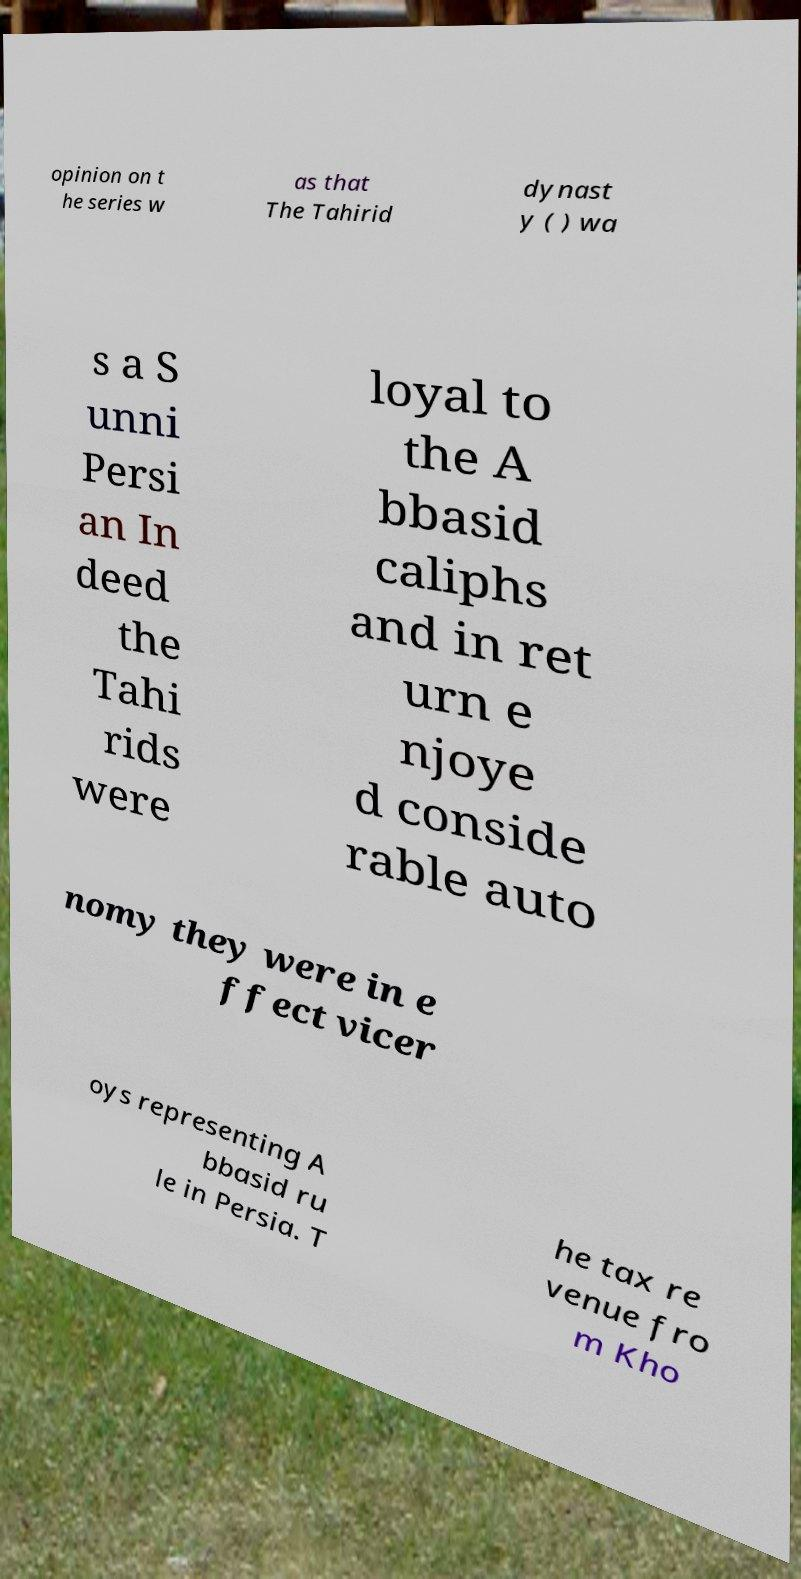What messages or text are displayed in this image? I need them in a readable, typed format. opinion on t he series w as that The Tahirid dynast y ( ) wa s a S unni Persi an In deed the Tahi rids were loyal to the A bbasid caliphs and in ret urn e njoye d conside rable auto nomy they were in e ffect vicer oys representing A bbasid ru le in Persia. T he tax re venue fro m Kho 